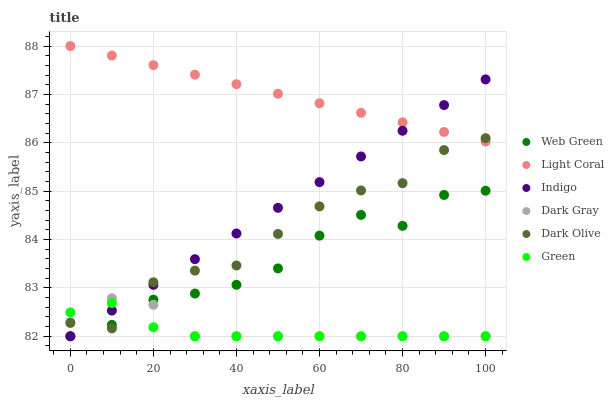Does Green have the minimum area under the curve?
Answer yes or no. Yes. Does Light Coral have the maximum area under the curve?
Answer yes or no. Yes. Does Indigo have the minimum area under the curve?
Answer yes or no. No. Does Indigo have the maximum area under the curve?
Answer yes or no. No. Is Indigo the smoothest?
Answer yes or no. Yes. Is Dark Olive the roughest?
Answer yes or no. Yes. Is Dark Olive the smoothest?
Answer yes or no. No. Is Indigo the roughest?
Answer yes or no. No. Does Dark Gray have the lowest value?
Answer yes or no. Yes. Does Dark Olive have the lowest value?
Answer yes or no. No. Does Light Coral have the highest value?
Answer yes or no. Yes. Does Indigo have the highest value?
Answer yes or no. No. Is Dark Gray less than Light Coral?
Answer yes or no. Yes. Is Light Coral greater than Web Green?
Answer yes or no. Yes. Does Dark Olive intersect Indigo?
Answer yes or no. Yes. Is Dark Olive less than Indigo?
Answer yes or no. No. Is Dark Olive greater than Indigo?
Answer yes or no. No. Does Dark Gray intersect Light Coral?
Answer yes or no. No. 